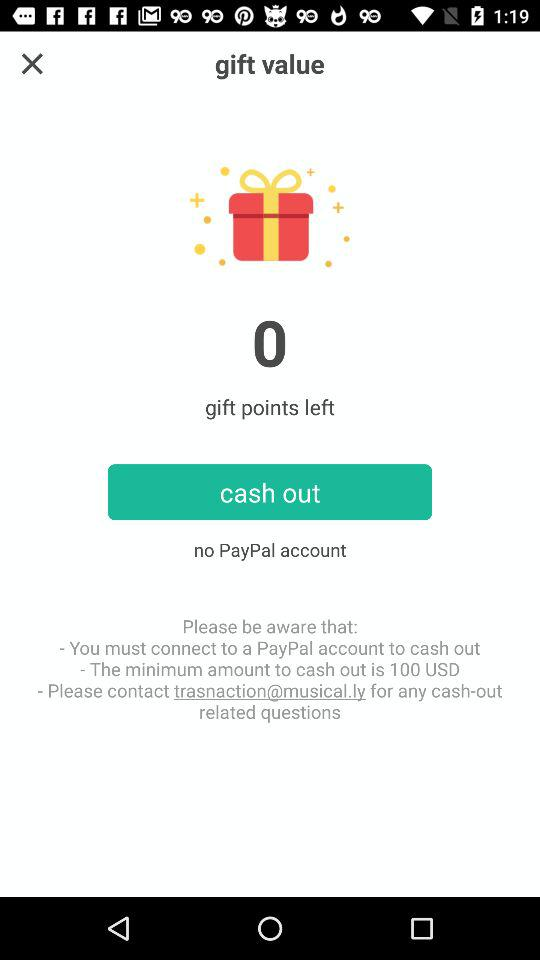How much is the maximum amount to cash out?
When the provided information is insufficient, respond with <no answer>. <no answer> 